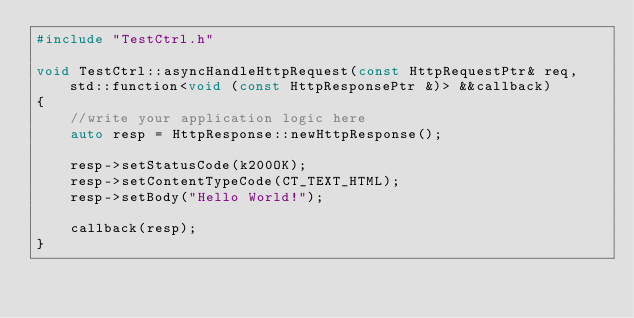<code> <loc_0><loc_0><loc_500><loc_500><_C++_>#include "TestCtrl.h"

void TestCtrl::asyncHandleHttpRequest(const HttpRequestPtr& req, std::function<void (const HttpResponsePtr &)> &&callback)
{
    //write your application logic here
    auto resp = HttpResponse::newHttpResponse();

    resp->setStatusCode(k200OK);
    resp->setContentTypeCode(CT_TEXT_HTML);
    resp->setBody("Hello World!");

    callback(resp);
}
</code> 